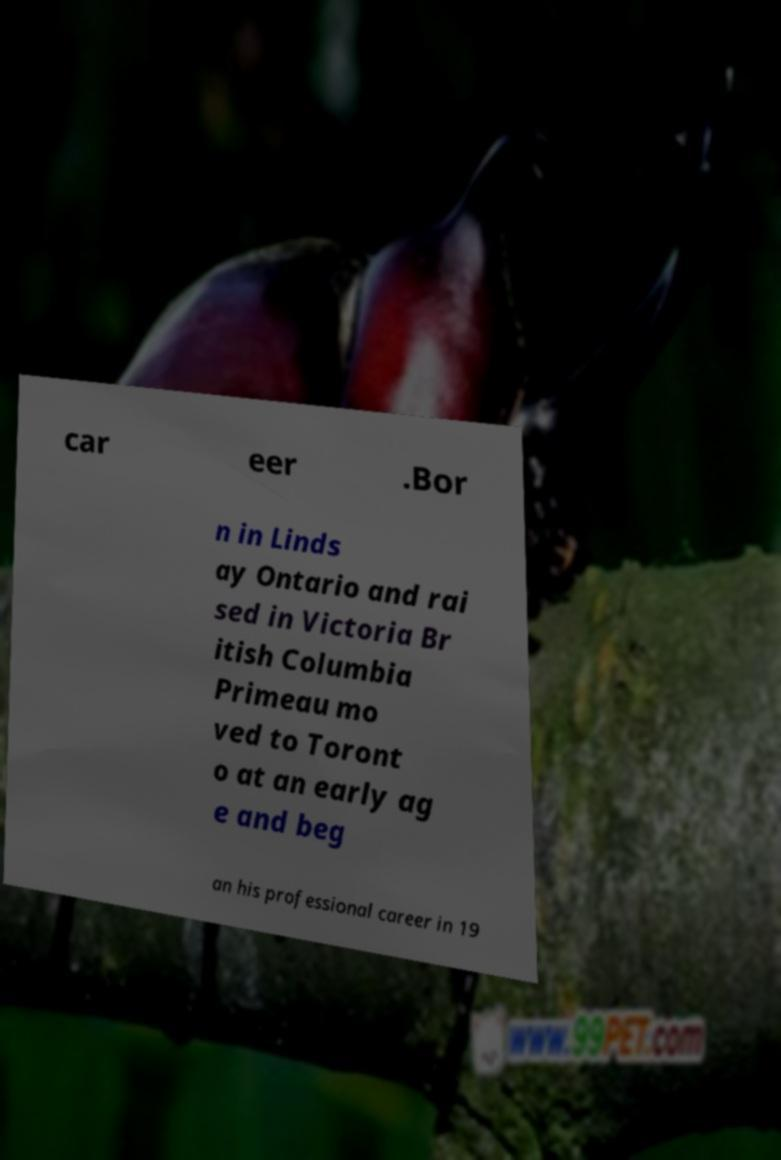What messages or text are displayed in this image? I need them in a readable, typed format. car eer .Bor n in Linds ay Ontario and rai sed in Victoria Br itish Columbia Primeau mo ved to Toront o at an early ag e and beg an his professional career in 19 